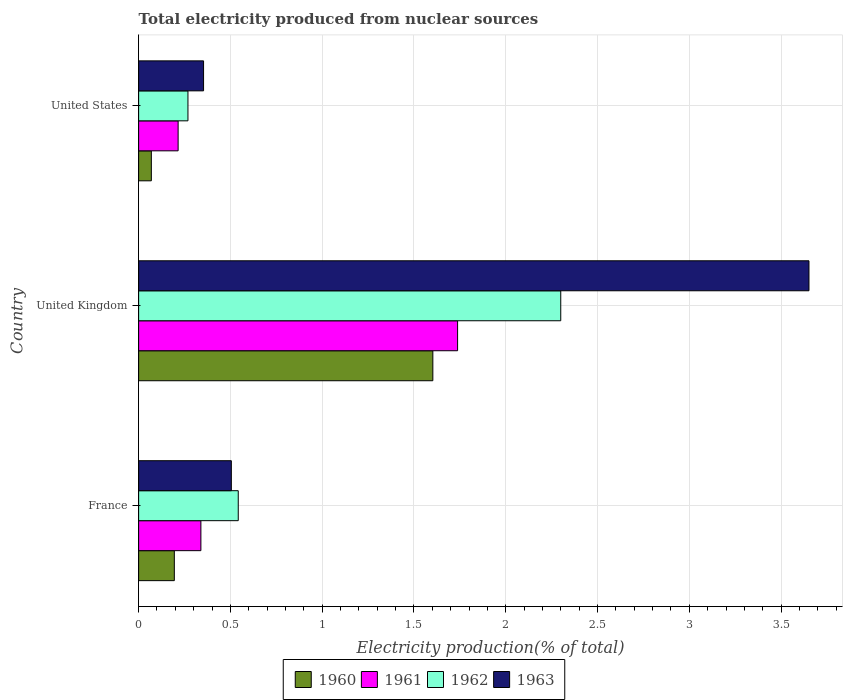How many groups of bars are there?
Provide a succinct answer. 3. Are the number of bars on each tick of the Y-axis equal?
Ensure brevity in your answer.  Yes. How many bars are there on the 2nd tick from the top?
Your answer should be very brief. 4. How many bars are there on the 3rd tick from the bottom?
Ensure brevity in your answer.  4. What is the label of the 2nd group of bars from the top?
Keep it short and to the point. United Kingdom. In how many cases, is the number of bars for a given country not equal to the number of legend labels?
Your answer should be very brief. 0. What is the total electricity produced in 1963 in United States?
Offer a terse response. 0.35. Across all countries, what is the maximum total electricity produced in 1960?
Provide a succinct answer. 1.6. Across all countries, what is the minimum total electricity produced in 1961?
Make the answer very short. 0.22. What is the total total electricity produced in 1961 in the graph?
Provide a short and direct response. 2.29. What is the difference between the total electricity produced in 1960 in France and that in United States?
Ensure brevity in your answer.  0.13. What is the difference between the total electricity produced in 1960 in United States and the total electricity produced in 1962 in France?
Ensure brevity in your answer.  -0.47. What is the average total electricity produced in 1961 per country?
Offer a terse response. 0.76. What is the difference between the total electricity produced in 1962 and total electricity produced in 1960 in United Kingdom?
Your response must be concise. 0.7. What is the ratio of the total electricity produced in 1963 in France to that in United States?
Your answer should be compact. 1.43. What is the difference between the highest and the second highest total electricity produced in 1961?
Make the answer very short. 1.4. What is the difference between the highest and the lowest total electricity produced in 1960?
Offer a terse response. 1.53. In how many countries, is the total electricity produced in 1963 greater than the average total electricity produced in 1963 taken over all countries?
Keep it short and to the point. 1. Is the sum of the total electricity produced in 1961 in France and United Kingdom greater than the maximum total electricity produced in 1963 across all countries?
Provide a short and direct response. No. Is it the case that in every country, the sum of the total electricity produced in 1960 and total electricity produced in 1963 is greater than the sum of total electricity produced in 1962 and total electricity produced in 1961?
Your response must be concise. No. What does the 1st bar from the top in United States represents?
Keep it short and to the point. 1963. What does the 2nd bar from the bottom in United States represents?
Your answer should be very brief. 1961. What is the difference between two consecutive major ticks on the X-axis?
Your response must be concise. 0.5. Does the graph contain grids?
Offer a terse response. Yes. Where does the legend appear in the graph?
Your answer should be compact. Bottom center. How many legend labels are there?
Your answer should be very brief. 4. What is the title of the graph?
Give a very brief answer. Total electricity produced from nuclear sources. What is the label or title of the X-axis?
Keep it short and to the point. Electricity production(% of total). What is the label or title of the Y-axis?
Make the answer very short. Country. What is the Electricity production(% of total) of 1960 in France?
Ensure brevity in your answer.  0.19. What is the Electricity production(% of total) in 1961 in France?
Ensure brevity in your answer.  0.34. What is the Electricity production(% of total) in 1962 in France?
Your response must be concise. 0.54. What is the Electricity production(% of total) in 1963 in France?
Make the answer very short. 0.51. What is the Electricity production(% of total) in 1960 in United Kingdom?
Your response must be concise. 1.6. What is the Electricity production(% of total) in 1961 in United Kingdom?
Offer a terse response. 1.74. What is the Electricity production(% of total) in 1962 in United Kingdom?
Give a very brief answer. 2.3. What is the Electricity production(% of total) of 1963 in United Kingdom?
Provide a succinct answer. 3.65. What is the Electricity production(% of total) of 1960 in United States?
Ensure brevity in your answer.  0.07. What is the Electricity production(% of total) of 1961 in United States?
Provide a succinct answer. 0.22. What is the Electricity production(% of total) in 1962 in United States?
Give a very brief answer. 0.27. What is the Electricity production(% of total) of 1963 in United States?
Your answer should be very brief. 0.35. Across all countries, what is the maximum Electricity production(% of total) in 1960?
Your answer should be very brief. 1.6. Across all countries, what is the maximum Electricity production(% of total) in 1961?
Give a very brief answer. 1.74. Across all countries, what is the maximum Electricity production(% of total) of 1962?
Provide a short and direct response. 2.3. Across all countries, what is the maximum Electricity production(% of total) of 1963?
Offer a terse response. 3.65. Across all countries, what is the minimum Electricity production(% of total) in 1960?
Your answer should be very brief. 0.07. Across all countries, what is the minimum Electricity production(% of total) of 1961?
Keep it short and to the point. 0.22. Across all countries, what is the minimum Electricity production(% of total) in 1962?
Your answer should be very brief. 0.27. Across all countries, what is the minimum Electricity production(% of total) of 1963?
Make the answer very short. 0.35. What is the total Electricity production(% of total) in 1960 in the graph?
Provide a short and direct response. 1.87. What is the total Electricity production(% of total) in 1961 in the graph?
Make the answer very short. 2.29. What is the total Electricity production(% of total) of 1962 in the graph?
Make the answer very short. 3.11. What is the total Electricity production(% of total) of 1963 in the graph?
Offer a very short reply. 4.51. What is the difference between the Electricity production(% of total) of 1960 in France and that in United Kingdom?
Provide a short and direct response. -1.41. What is the difference between the Electricity production(% of total) in 1961 in France and that in United Kingdom?
Provide a succinct answer. -1.4. What is the difference between the Electricity production(% of total) of 1962 in France and that in United Kingdom?
Provide a short and direct response. -1.76. What is the difference between the Electricity production(% of total) in 1963 in France and that in United Kingdom?
Offer a very short reply. -3.15. What is the difference between the Electricity production(% of total) of 1960 in France and that in United States?
Give a very brief answer. 0.13. What is the difference between the Electricity production(% of total) of 1961 in France and that in United States?
Give a very brief answer. 0.12. What is the difference between the Electricity production(% of total) of 1962 in France and that in United States?
Provide a succinct answer. 0.27. What is the difference between the Electricity production(% of total) of 1963 in France and that in United States?
Ensure brevity in your answer.  0.15. What is the difference between the Electricity production(% of total) in 1960 in United Kingdom and that in United States?
Ensure brevity in your answer.  1.53. What is the difference between the Electricity production(% of total) in 1961 in United Kingdom and that in United States?
Your answer should be very brief. 1.52. What is the difference between the Electricity production(% of total) in 1962 in United Kingdom and that in United States?
Offer a terse response. 2.03. What is the difference between the Electricity production(% of total) in 1963 in United Kingdom and that in United States?
Give a very brief answer. 3.3. What is the difference between the Electricity production(% of total) in 1960 in France and the Electricity production(% of total) in 1961 in United Kingdom?
Keep it short and to the point. -1.54. What is the difference between the Electricity production(% of total) of 1960 in France and the Electricity production(% of total) of 1962 in United Kingdom?
Offer a terse response. -2.11. What is the difference between the Electricity production(% of total) of 1960 in France and the Electricity production(% of total) of 1963 in United Kingdom?
Your response must be concise. -3.46. What is the difference between the Electricity production(% of total) in 1961 in France and the Electricity production(% of total) in 1962 in United Kingdom?
Give a very brief answer. -1.96. What is the difference between the Electricity production(% of total) in 1961 in France and the Electricity production(% of total) in 1963 in United Kingdom?
Make the answer very short. -3.31. What is the difference between the Electricity production(% of total) of 1962 in France and the Electricity production(% of total) of 1963 in United Kingdom?
Your response must be concise. -3.11. What is the difference between the Electricity production(% of total) in 1960 in France and the Electricity production(% of total) in 1961 in United States?
Provide a short and direct response. -0.02. What is the difference between the Electricity production(% of total) of 1960 in France and the Electricity production(% of total) of 1962 in United States?
Provide a succinct answer. -0.07. What is the difference between the Electricity production(% of total) of 1960 in France and the Electricity production(% of total) of 1963 in United States?
Provide a short and direct response. -0.16. What is the difference between the Electricity production(% of total) in 1961 in France and the Electricity production(% of total) in 1962 in United States?
Offer a terse response. 0.07. What is the difference between the Electricity production(% of total) of 1961 in France and the Electricity production(% of total) of 1963 in United States?
Provide a short and direct response. -0.01. What is the difference between the Electricity production(% of total) of 1962 in France and the Electricity production(% of total) of 1963 in United States?
Give a very brief answer. 0.19. What is the difference between the Electricity production(% of total) of 1960 in United Kingdom and the Electricity production(% of total) of 1961 in United States?
Make the answer very short. 1.39. What is the difference between the Electricity production(% of total) in 1960 in United Kingdom and the Electricity production(% of total) in 1962 in United States?
Offer a very short reply. 1.33. What is the difference between the Electricity production(% of total) of 1960 in United Kingdom and the Electricity production(% of total) of 1963 in United States?
Provide a short and direct response. 1.25. What is the difference between the Electricity production(% of total) in 1961 in United Kingdom and the Electricity production(% of total) in 1962 in United States?
Give a very brief answer. 1.47. What is the difference between the Electricity production(% of total) of 1961 in United Kingdom and the Electricity production(% of total) of 1963 in United States?
Provide a succinct answer. 1.38. What is the difference between the Electricity production(% of total) of 1962 in United Kingdom and the Electricity production(% of total) of 1963 in United States?
Your answer should be very brief. 1.95. What is the average Electricity production(% of total) in 1960 per country?
Give a very brief answer. 0.62. What is the average Electricity production(% of total) in 1961 per country?
Offer a terse response. 0.76. What is the average Electricity production(% of total) in 1963 per country?
Ensure brevity in your answer.  1.5. What is the difference between the Electricity production(% of total) in 1960 and Electricity production(% of total) in 1961 in France?
Offer a very short reply. -0.14. What is the difference between the Electricity production(% of total) of 1960 and Electricity production(% of total) of 1962 in France?
Provide a short and direct response. -0.35. What is the difference between the Electricity production(% of total) in 1960 and Electricity production(% of total) in 1963 in France?
Your answer should be very brief. -0.31. What is the difference between the Electricity production(% of total) in 1961 and Electricity production(% of total) in 1962 in France?
Your answer should be compact. -0.2. What is the difference between the Electricity production(% of total) in 1961 and Electricity production(% of total) in 1963 in France?
Your answer should be compact. -0.17. What is the difference between the Electricity production(% of total) in 1962 and Electricity production(% of total) in 1963 in France?
Keep it short and to the point. 0.04. What is the difference between the Electricity production(% of total) in 1960 and Electricity production(% of total) in 1961 in United Kingdom?
Offer a terse response. -0.13. What is the difference between the Electricity production(% of total) of 1960 and Electricity production(% of total) of 1962 in United Kingdom?
Provide a succinct answer. -0.7. What is the difference between the Electricity production(% of total) of 1960 and Electricity production(% of total) of 1963 in United Kingdom?
Provide a short and direct response. -2.05. What is the difference between the Electricity production(% of total) of 1961 and Electricity production(% of total) of 1962 in United Kingdom?
Your answer should be compact. -0.56. What is the difference between the Electricity production(% of total) in 1961 and Electricity production(% of total) in 1963 in United Kingdom?
Your answer should be very brief. -1.91. What is the difference between the Electricity production(% of total) in 1962 and Electricity production(% of total) in 1963 in United Kingdom?
Give a very brief answer. -1.35. What is the difference between the Electricity production(% of total) of 1960 and Electricity production(% of total) of 1961 in United States?
Provide a short and direct response. -0.15. What is the difference between the Electricity production(% of total) of 1960 and Electricity production(% of total) of 1962 in United States?
Ensure brevity in your answer.  -0.2. What is the difference between the Electricity production(% of total) in 1960 and Electricity production(% of total) in 1963 in United States?
Your response must be concise. -0.28. What is the difference between the Electricity production(% of total) in 1961 and Electricity production(% of total) in 1962 in United States?
Provide a short and direct response. -0.05. What is the difference between the Electricity production(% of total) of 1961 and Electricity production(% of total) of 1963 in United States?
Offer a very short reply. -0.14. What is the difference between the Electricity production(% of total) in 1962 and Electricity production(% of total) in 1963 in United States?
Provide a succinct answer. -0.09. What is the ratio of the Electricity production(% of total) of 1960 in France to that in United Kingdom?
Offer a terse response. 0.12. What is the ratio of the Electricity production(% of total) in 1961 in France to that in United Kingdom?
Offer a very short reply. 0.2. What is the ratio of the Electricity production(% of total) of 1962 in France to that in United Kingdom?
Keep it short and to the point. 0.24. What is the ratio of the Electricity production(% of total) of 1963 in France to that in United Kingdom?
Provide a short and direct response. 0.14. What is the ratio of the Electricity production(% of total) in 1960 in France to that in United States?
Make the answer very short. 2.81. What is the ratio of the Electricity production(% of total) of 1961 in France to that in United States?
Your answer should be compact. 1.58. What is the ratio of the Electricity production(% of total) in 1962 in France to that in United States?
Offer a very short reply. 2.02. What is the ratio of the Electricity production(% of total) of 1963 in France to that in United States?
Ensure brevity in your answer.  1.43. What is the ratio of the Electricity production(% of total) in 1960 in United Kingdom to that in United States?
Provide a succinct answer. 23.14. What is the ratio of the Electricity production(% of total) of 1961 in United Kingdom to that in United States?
Keep it short and to the point. 8.08. What is the ratio of the Electricity production(% of total) in 1962 in United Kingdom to that in United States?
Offer a terse response. 8.56. What is the ratio of the Electricity production(% of total) of 1963 in United Kingdom to that in United States?
Offer a very short reply. 10.32. What is the difference between the highest and the second highest Electricity production(% of total) of 1960?
Offer a very short reply. 1.41. What is the difference between the highest and the second highest Electricity production(% of total) of 1961?
Provide a short and direct response. 1.4. What is the difference between the highest and the second highest Electricity production(% of total) of 1962?
Ensure brevity in your answer.  1.76. What is the difference between the highest and the second highest Electricity production(% of total) in 1963?
Your answer should be compact. 3.15. What is the difference between the highest and the lowest Electricity production(% of total) in 1960?
Make the answer very short. 1.53. What is the difference between the highest and the lowest Electricity production(% of total) of 1961?
Offer a terse response. 1.52. What is the difference between the highest and the lowest Electricity production(% of total) in 1962?
Offer a terse response. 2.03. What is the difference between the highest and the lowest Electricity production(% of total) in 1963?
Ensure brevity in your answer.  3.3. 